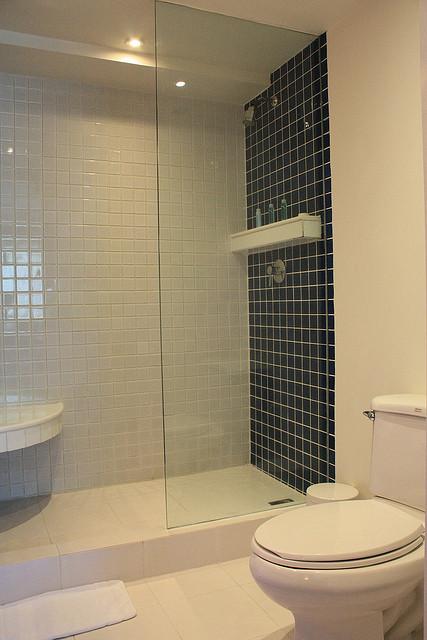Is this bathroom fancy?
Short answer required. No. Is the shower on?
Give a very brief answer. No. Is there a toilet?
Write a very short answer. Yes. 